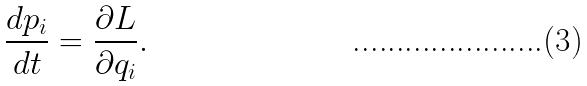Convert formula to latex. <formula><loc_0><loc_0><loc_500><loc_500>\frac { d p _ { i } } { d t } = \frac { \partial L } { \partial q _ { i } } .</formula> 